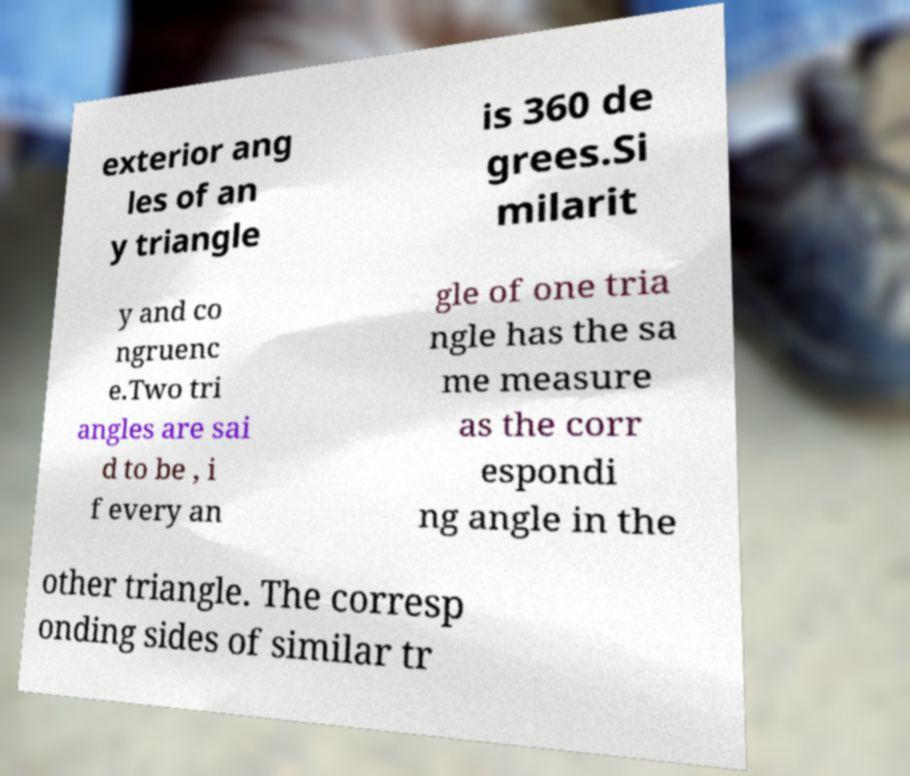Could you assist in decoding the text presented in this image and type it out clearly? exterior ang les of an y triangle is 360 de grees.Si milarit y and co ngruenc e.Two tri angles are sai d to be , i f every an gle of one tria ngle has the sa me measure as the corr espondi ng angle in the other triangle. The corresp onding sides of similar tr 